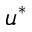Convert formula to latex. <formula><loc_0><loc_0><loc_500><loc_500>u ^ { * }</formula> 